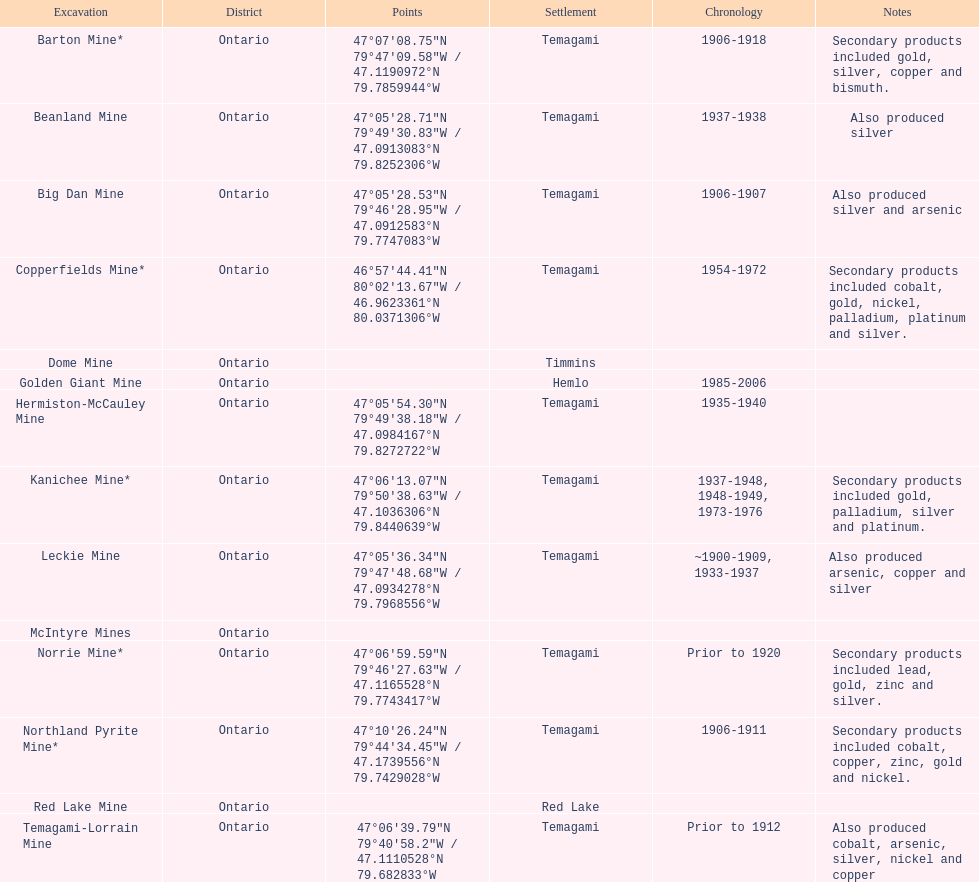How many mines were in temagami? 10. 